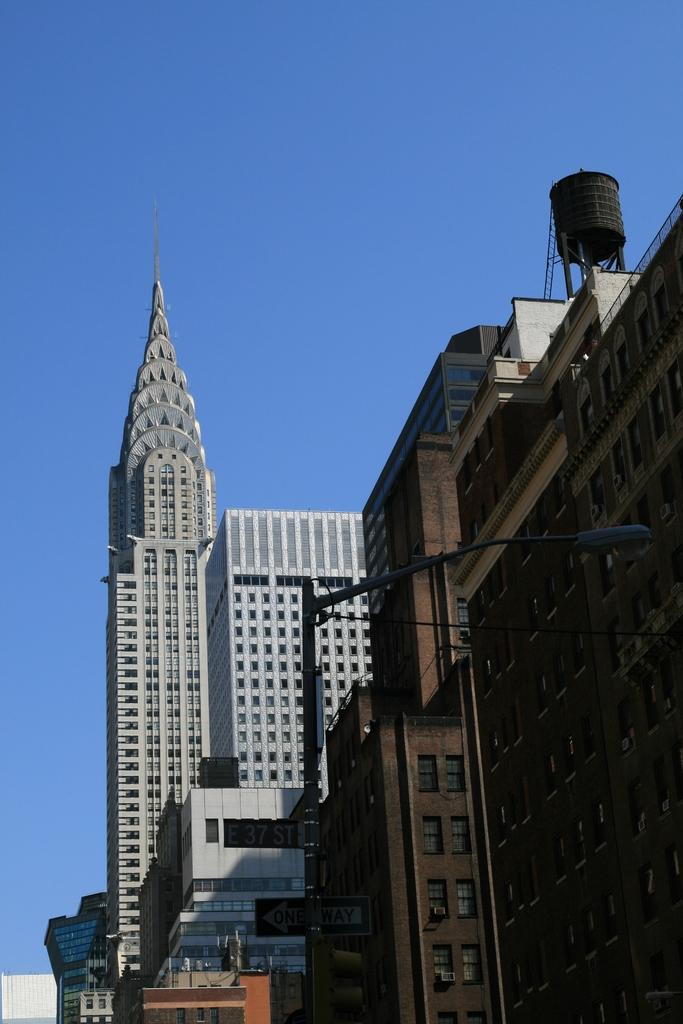What type of structures are present in the image? There are buildings with windows in the image. Can you describe any specific details about the buildings? Some of the windows have text written on them. What else can be seen in the image besides the buildings? There is an electric pole in the image. What is visible at the top of the image? The sky is visible at the top of the image. What type of alarm is being used by the carpenter in the image? There is no carpenter or alarm present in the image. 